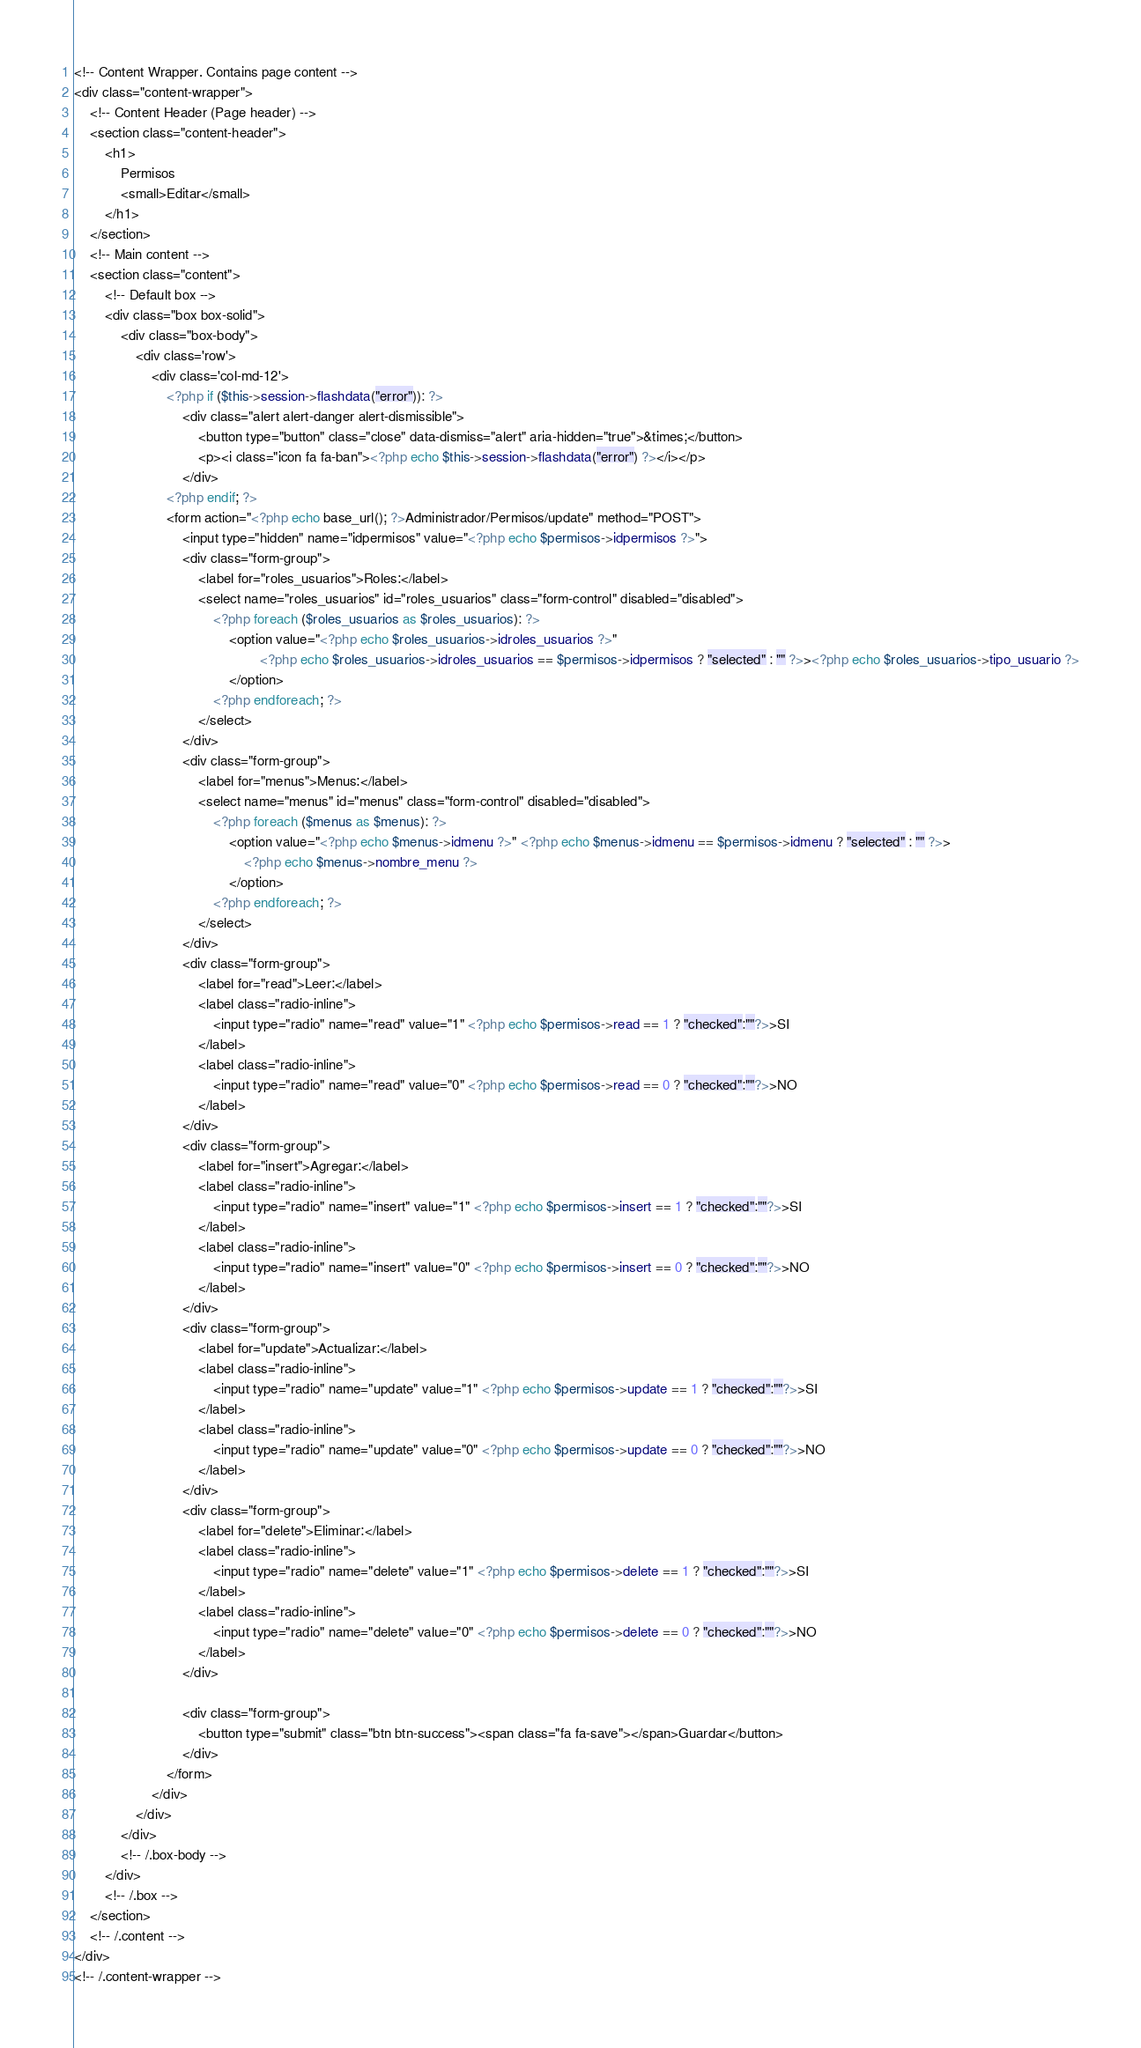Convert code to text. <code><loc_0><loc_0><loc_500><loc_500><_PHP_>
<!-- Content Wrapper. Contains page content -->
<div class="content-wrapper">
    <!-- Content Header (Page header) -->
    <section class="content-header">
        <h1>
            Permisos
            <small>Editar</small>
        </h1>
    </section>
    <!-- Main content -->
    <section class="content">
        <!-- Default box -->
        <div class="box box-solid">
            <div class="box-body">
                <div class='row'>
                    <div class='col-md-12'>
                        <?php if ($this->session->flashdata("error")): ?>
                            <div class="alert alert-danger alert-dismissible">
                                <button type="button" class="close" data-dismiss="alert" aria-hidden="true">&times;</button>
                                <p><i class="icon fa fa-ban"><?php echo $this->session->flashdata("error") ?></i></p>
                            </div>
                        <?php endif; ?>
                        <form action="<?php echo base_url(); ?>Administrador/Permisos/update" method="POST">
                            <input type="hidden" name="idpermisos" value="<?php echo $permisos->idpermisos ?>">
                            <div class="form-group">
                                <label for="roles_usuarios">Roles:</label>
                                <select name="roles_usuarios" id="roles_usuarios" class="form-control" disabled="disabled">
                                    <?php foreach ($roles_usuarios as $roles_usuarios): ?>
                                        <option value="<?php echo $roles_usuarios->idroles_usuarios ?>" 
                                                <?php echo $roles_usuarios->idroles_usuarios == $permisos->idpermisos ? "selected" : "" ?>><?php echo $roles_usuarios->tipo_usuario ?>
                                        </option>
                                    <?php endforeach; ?>
                                </select>
                            </div>
                            <div class="form-group">
                                <label for="menus">Menus:</label>
                                <select name="menus" id="menus" class="form-control" disabled="disabled">
                                    <?php foreach ($menus as $menus): ?>
                                        <option value="<?php echo $menus->idmenu ?>" <?php echo $menus->idmenu == $permisos->idmenu ? "selected" : "" ?>>
                                            <?php echo $menus->nombre_menu ?>
                                        </option>
                                    <?php endforeach; ?>
                                </select>
                            </div>
                            <div class="form-group">
                                <label for="read">Leer:</label>
                                <label class="radio-inline">
                                    <input type="radio" name="read" value="1" <?php echo $permisos->read == 1 ? "checked":""?>>SI 
                                </label>
                                <label class="radio-inline">
                                    <input type="radio" name="read" value="0" <?php echo $permisos->read == 0 ? "checked":""?>>NO 
                                </label>
                            </div>
                            <div class="form-group">
                                <label for="insert">Agregar:</label>
                                <label class="radio-inline">
                                    <input type="radio" name="insert" value="1" <?php echo $permisos->insert == 1 ? "checked":""?>>SI 
                                </label>
                                <label class="radio-inline">
                                    <input type="radio" name="insert" value="0" <?php echo $permisos->insert == 0 ? "checked":""?>>NO 
                                </label>
                            </div>
                            <div class="form-group">
                                <label for="update">Actualizar:</label>
                                <label class="radio-inline">
                                    <input type="radio" name="update" value="1" <?php echo $permisos->update == 1 ? "checked":""?>>SI 
                                </label>
                                <label class="radio-inline">
                                    <input type="radio" name="update" value="0" <?php echo $permisos->update == 0 ? "checked":""?>>NO 
                                </label>
                            </div>
                            <div class="form-group">
                                <label for="delete">Eliminar:</label>
                                <label class="radio-inline">
                                    <input type="radio" name="delete" value="1" <?php echo $permisos->delete == 1 ? "checked":""?>>SI 
                                </label>
                                <label class="radio-inline">
                                    <input type="radio" name="delete" value="0" <?php echo $permisos->delete == 0 ? "checked":""?>>NO 
                                </label>
                            </div>

                            <div class="form-group">
                                <button type="submit" class="btn btn-success"><span class="fa fa-save"></span>Guardar</button>
                            </div>
                        </form>
                    </div>
                </div>
            </div>
            <!-- /.box-body -->
        </div>
        <!-- /.box -->
    </section>
    <!-- /.content -->
</div>
<!-- /.content-wrapper -->
</code> 